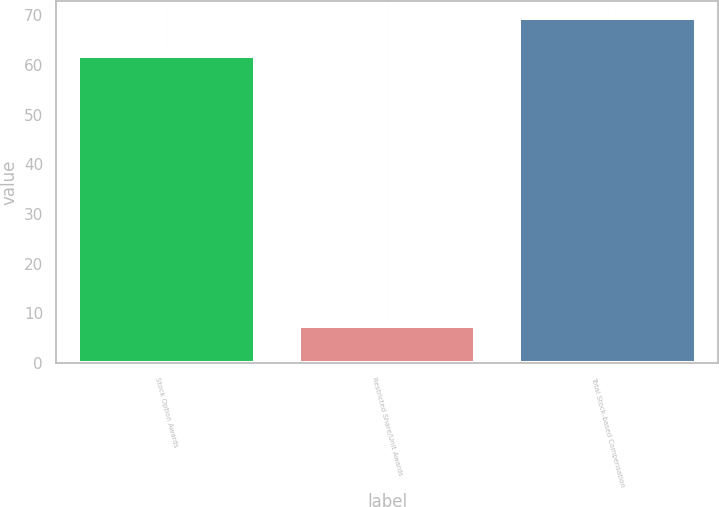<chart> <loc_0><loc_0><loc_500><loc_500><bar_chart><fcel>Stock Option Awards<fcel>Restricted Share/Unit Awards<fcel>Total Stock-based Compensation<nl><fcel>61.9<fcel>7.5<fcel>69.4<nl></chart> 